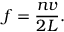<formula> <loc_0><loc_0><loc_500><loc_500>f = { \frac { n v } { 2 L } } .</formula> 